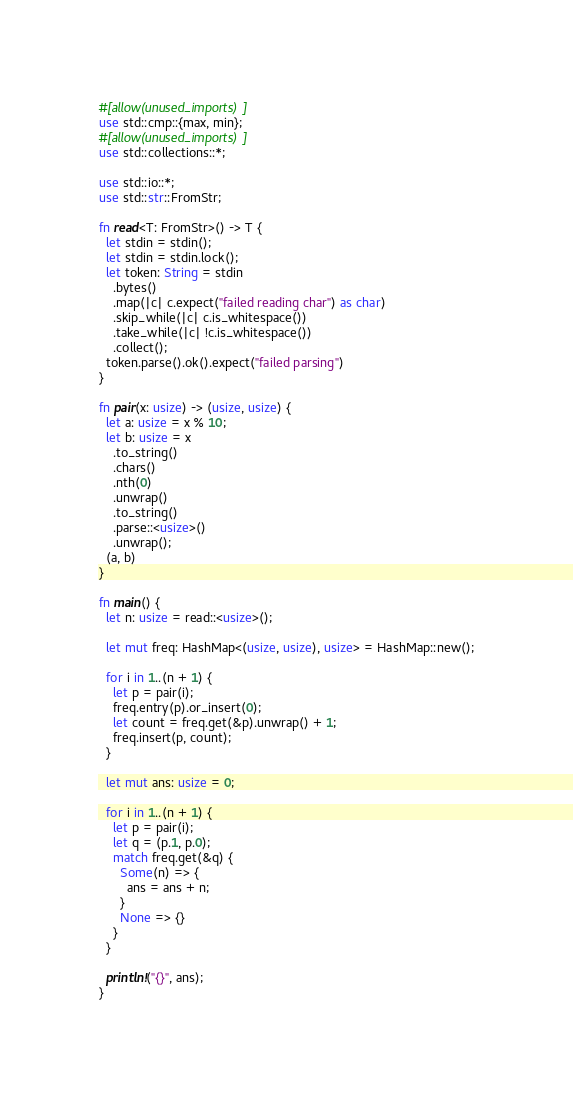Convert code to text. <code><loc_0><loc_0><loc_500><loc_500><_Rust_>#[allow(unused_imports)]
use std::cmp::{max, min};
#[allow(unused_imports)]
use std::collections::*;

use std::io::*;
use std::str::FromStr;

fn read<T: FromStr>() -> T {
  let stdin = stdin();
  let stdin = stdin.lock();
  let token: String = stdin
    .bytes()
    .map(|c| c.expect("failed reading char") as char)
    .skip_while(|c| c.is_whitespace())
    .take_while(|c| !c.is_whitespace())
    .collect();
  token.parse().ok().expect("failed parsing")
}

fn pair(x: usize) -> (usize, usize) {
  let a: usize = x % 10;
  let b: usize = x
    .to_string()
    .chars()
    .nth(0)
    .unwrap()
    .to_string()
    .parse::<usize>()
    .unwrap();
  (a, b)
}

fn main() {
  let n: usize = read::<usize>();

  let mut freq: HashMap<(usize, usize), usize> = HashMap::new();

  for i in 1..(n + 1) {
    let p = pair(i);
    freq.entry(p).or_insert(0);
    let count = freq.get(&p).unwrap() + 1;
    freq.insert(p, count);
  }

  let mut ans: usize = 0;

  for i in 1..(n + 1) {
    let p = pair(i);
    let q = (p.1, p.0);
    match freq.get(&q) {
      Some(n) => {
        ans = ans + n;
      }
      None => {}
    }
  }

  println!("{}", ans);
}
</code> 